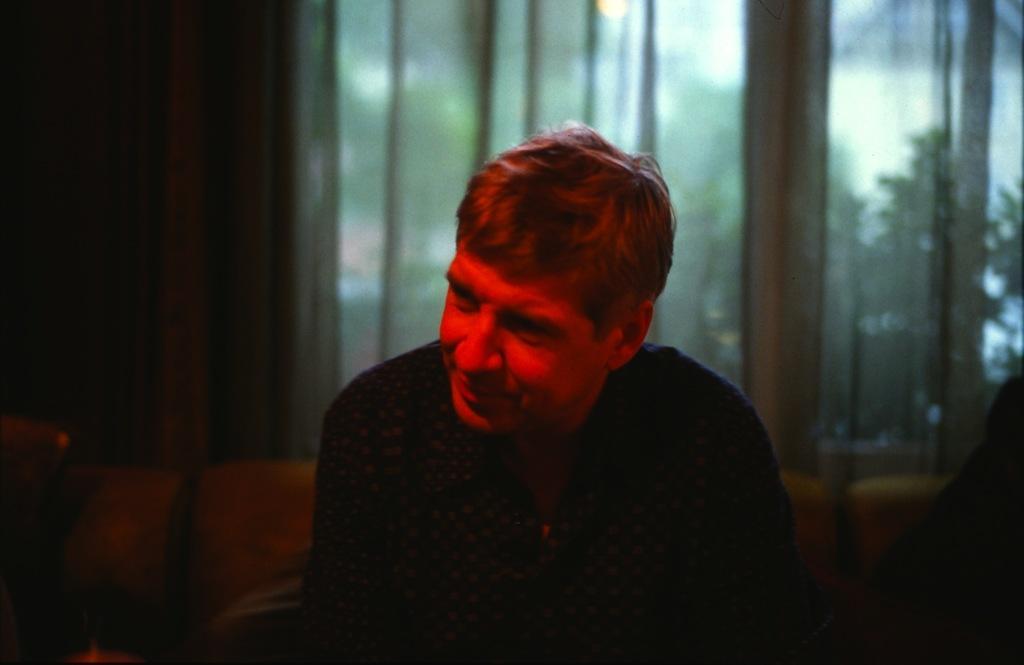Please provide a concise description of this image. In the image we can see a person wearing clothes and the person is smiling. Behind the person there is a window and these are the curtains of the window, out of the window we can see a tree. 